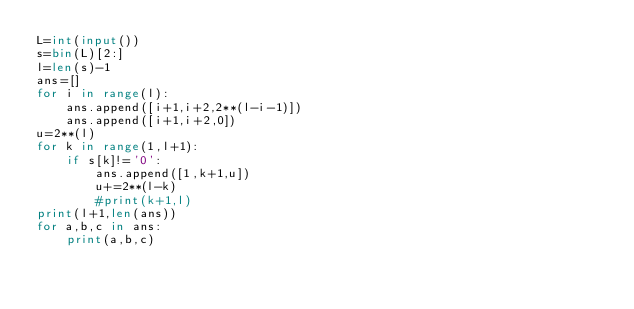Convert code to text. <code><loc_0><loc_0><loc_500><loc_500><_Python_>L=int(input())
s=bin(L)[2:]
l=len(s)-1
ans=[]
for i in range(l):
    ans.append([i+1,i+2,2**(l-i-1)])
    ans.append([i+1,i+2,0])
u=2**(l)
for k in range(1,l+1):
    if s[k]!='0':
        ans.append([1,k+1,u])
        u+=2**(l-k) 
        #print(k+1,l)
print(l+1,len(ans))
for a,b,c in ans:
    print(a,b,c)</code> 